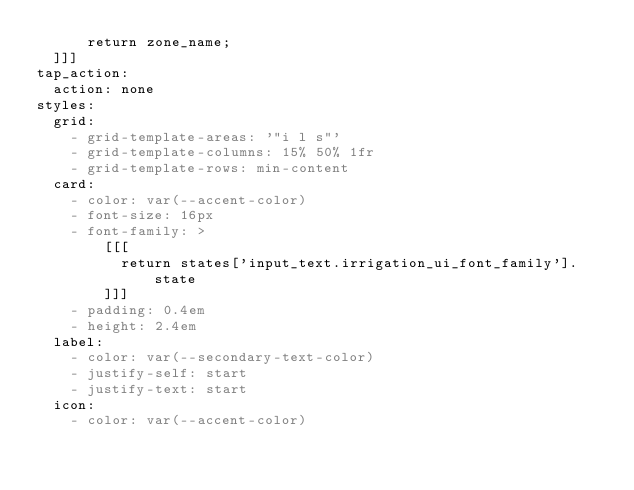<code> <loc_0><loc_0><loc_500><loc_500><_YAML_>      return zone_name;
  ]]]
tap_action:
  action: none
styles:
  grid:
    - grid-template-areas: '"i l s"'
    - grid-template-columns: 15% 50% 1fr
    - grid-template-rows: min-content
  card:
    - color: var(--accent-color)
    - font-size: 16px
    - font-family: >
        [[[
          return states['input_text.irrigation_ui_font_family'].state
        ]]]
    - padding: 0.4em
    - height: 2.4em
  label:
    - color: var(--secondary-text-color)
    - justify-self: start
    - justify-text: start
  icon:
    - color: var(--accent-color)
</code> 